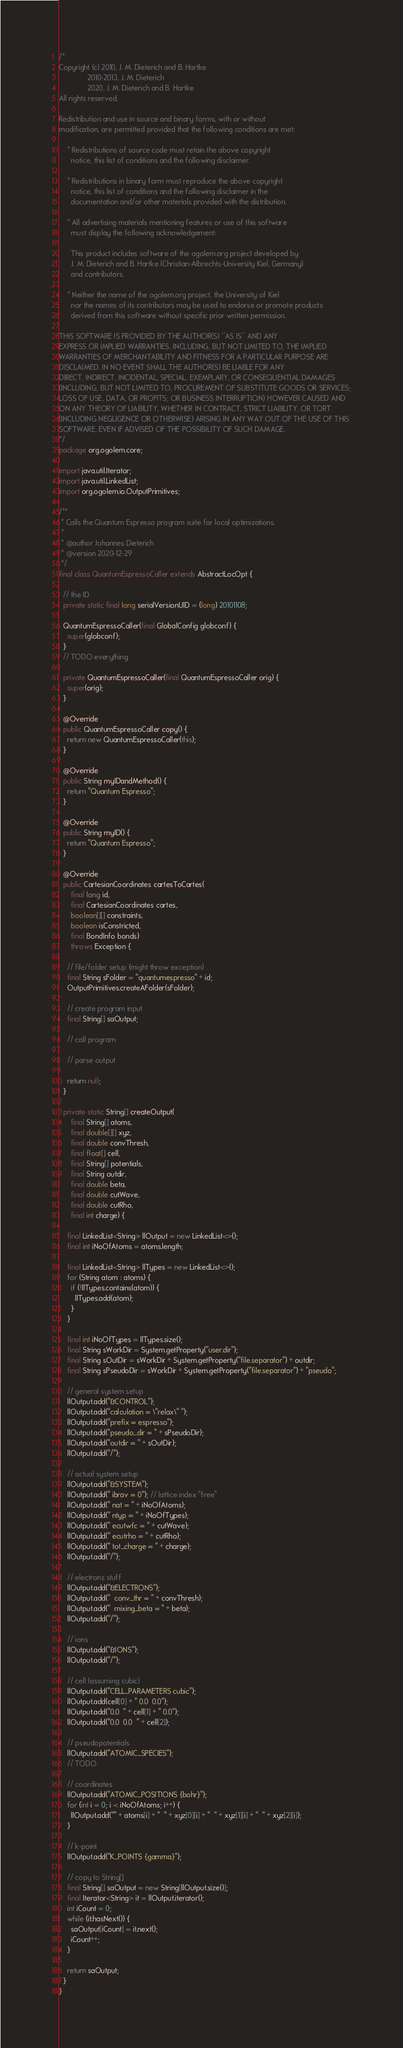<code> <loc_0><loc_0><loc_500><loc_500><_Java_>/*
Copyright (c) 2010, J. M. Dieterich and B. Hartke
              2010-2013, J. M. Dieterich
              2020, J. M. Dieterich and B. Hartke
All rights reserved.

Redistribution and use in source and binary forms, with or without
modification, are permitted provided that the following conditions are met:

    * Redistributions of source code must retain the above copyright
      notice, this list of conditions and the following disclaimer.

    * Redistributions in binary form must reproduce the above copyright
      notice, this list of conditions and the following disclaimer in the
      documentation and/or other materials provided with the distribution.

    * All advertising materials mentioning features or use of this software
      must display the following acknowledgement:

      This product includes software of the ogolem.org project developed by
      J. M. Dieterich and B. Hartke (Christian-Albrechts-University Kiel, Germany)
      and contributors.

    * Neither the name of the ogolem.org project, the University of Kiel
      nor the names of its contributors may be used to endorse or promote products
      derived from this software without specific prior written permission.

THIS SOFTWARE IS PROVIDED BY THE AUTHOR(S) ''AS IS'' AND ANY
EXPRESS OR IMPLIED WARRANTIES, INCLUDING, BUT NOT LIMITED TO, THE IMPLIED
WARRANTIES OF MERCHANTABILITY AND FITNESS FOR A PARTICULAR PURPOSE ARE
DISCLAIMED. IN NO EVENT SHALL THE AUTHOR(S) BE LIABLE FOR ANY
DIRECT, INDIRECT, INCIDENTAL, SPECIAL, EXEMPLARY, OR CONSEQUENTIAL DAMAGES
(INCLUDING, BUT NOT LIMITED TO, PROCUREMENT OF SUBSTITUTE GOODS OR SERVICES;
LOSS OF USE, DATA, OR PROFITS; OR BUSINESS INTERRUPTION) HOWEVER CAUSED AND
ON ANY THEORY OF LIABILITY, WHETHER IN CONTRACT, STRICT LIABILITY, OR TORT
(INCLUDING NEGLIGENCE OR OTHERWISE) ARISING IN ANY WAY OUT OF THE USE OF THIS
SOFTWARE, EVEN IF ADVISED OF THE POSSIBILITY OF SUCH DAMAGE.
*/
package org.ogolem.core;

import java.util.Iterator;
import java.util.LinkedList;
import org.ogolem.io.OutputPrimitives;

/**
 * Calls the Quantum Espresso program suite for local optimizations.
 *
 * @author Johannes Dieterich
 * @version 2020-12-29
 */
final class QuantumEspressoCaller extends AbstractLocOpt {

  // the ID
  private static final long serialVersionUID = (long) 20101108;

  QuantumEspressoCaller(final GlobalConfig globconf) {
    super(globconf);
  }
  // TODO everything

  private QuantumEspressoCaller(final QuantumEspressoCaller orig) {
    super(orig);
  }

  @Override
  public QuantumEspressoCaller copy() {
    return new QuantumEspressoCaller(this);
  }

  @Override
  public String myIDandMethod() {
    return "Quantum Espresso";
  }

  @Override
  public String myID() {
    return "Quantum Espresso";
  }

  @Override
  public CartesianCoordinates cartesToCartes(
      final long id,
      final CartesianCoordinates cartes,
      boolean[][] constraints,
      boolean isConstricted,
      final BondInfo bonds)
      throws Exception {

    // file/folder setup (might throw exception)
    final String sFolder = "quantumespresso" + id;
    OutputPrimitives.createAFolder(sFolder);

    // create program input
    final String[] saOutput;

    // call program

    // parse output

    return null;
  }

  private static String[] createOutput(
      final String[] atoms,
      final double[][] xyz,
      final double convThresh,
      final float[] cell,
      final String[] potentials,
      final String outdir,
      final double beta,
      final double cutWave,
      final double cutRho,
      final int charge) {

    final LinkedList<String> llOutput = new LinkedList<>();
    final int iNoOfAtoms = atoms.length;

    final LinkedList<String> llTypes = new LinkedList<>();
    for (String atom : atoms) {
      if (!llTypes.contains(atom)) {
        llTypes.add(atom);
      }
    }

    final int iNoOfTypes = llTypes.size();
    final String sWorkDir = System.getProperty("user.dir");
    final String sOutDir = sWorkDir + System.getProperty("file.separator") + outdir;
    final String sPseudoDir = sWorkDir + System.getProperty("file.separator") + "pseudo";

    // general system setup
    llOutput.add("&CONTROL");
    llOutput.add("calculation = \"relax\" ");
    llOutput.add("prefix = espresso");
    llOutput.add("pseudo_dir = " + sPseudoDir);
    llOutput.add("outdir = " + sOutDir);
    llOutput.add("/");

    // actual system setup
    llOutput.add("&SYSTEM");
    llOutput.add(" ibrav = 0"); // lattice index "free"
    llOutput.add(" nat = " + iNoOfAtoms);
    llOutput.add(" ntyp = " + iNoOfTypes);
    llOutput.add(" ecutwfc = " + cutWave);
    llOutput.add(" ecutrho = " + cutRho);
    llOutput.add(" tot_charge = " + charge);
    llOutput.add("/");

    // electrons stuff
    llOutput.add("&ELECTRONS");
    llOutput.add("  conv_thr = " + convThresh);
    llOutput.add("  mixing_beta = " + beta);
    llOutput.add("/");

    // ions
    llOutput.add("&IONS");
    llOutput.add("/");

    // cell (assuming cubic)
    llOutput.add("CELL_PARAMETERS cubic");
    llOutput.add(cell[0] + " 0.0  0.0");
    llOutput.add("0.0  " + cell[1] + " 0.0");
    llOutput.add("0.0  0.0  " + cell[2]);

    // pseudopotentials
    llOutput.add("ATOMIC_SPECIES");
    // TODO

    // coordinates
    llOutput.add("ATOMIC_POSITIONS {bohr}");
    for (int i = 0; i < iNoOfAtoms; i++) {
      llOutput.add("" + atoms[i] + "  " + xyz[0][i] + "  " + xyz[1][i] + "  " + xyz[2][i]);
    }

    // k-point
    llOutput.add("K_POINTS {gamma}");

    // copy to String[]
    final String[] saOutput = new String[llOutput.size()];
    final Iterator<String> it = llOutput.iterator();
    int iCount = 0;
    while (it.hasNext()) {
      saOutput[iCount] = it.next();
      iCount++;
    }

    return saOutput;
  }
}
</code> 